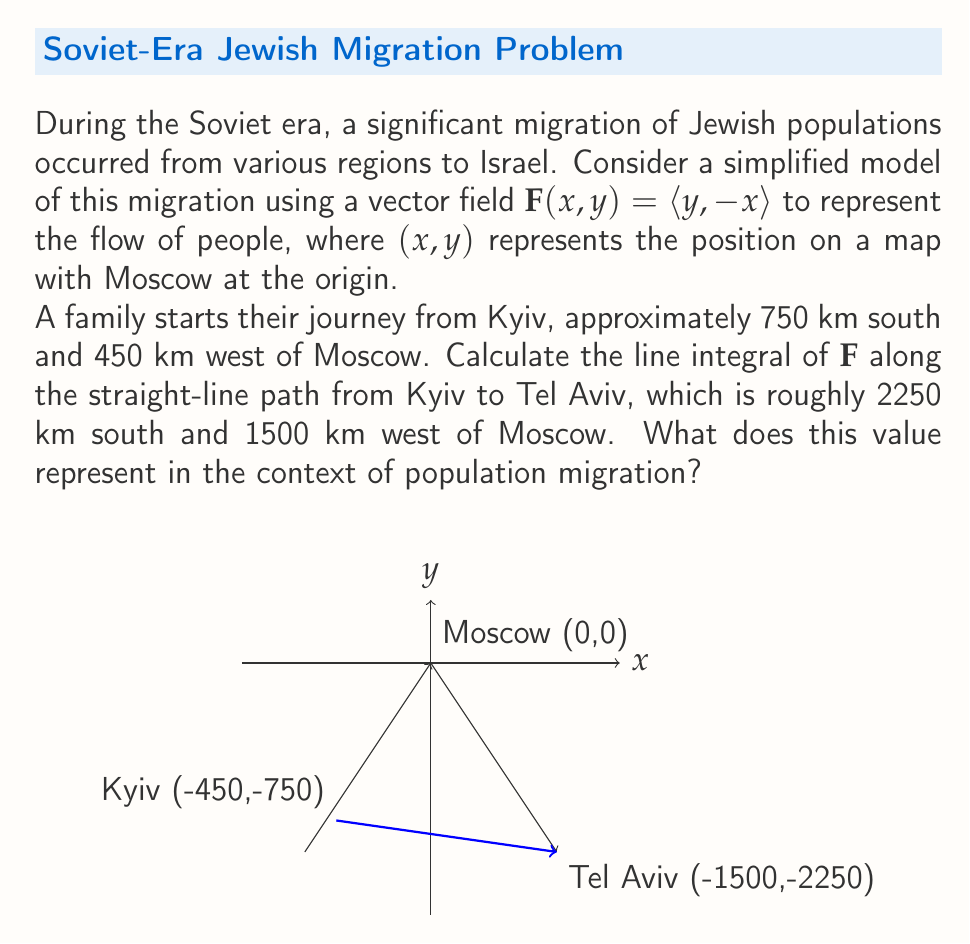Teach me how to tackle this problem. Let's approach this step-by-step:

1) The vector field is given as $\mathbf{F}(x,y) = \langle y, -x \rangle$.

2) We need to calculate the line integral of $\mathbf{F}$ along the straight line from Kyiv to Tel Aviv.

3) Let's parameterize this line. If we consider $t \in [0,1]$, we can write:
   $x(t) = -450 - 1050t$
   $y(t) = -750 - 1500t$

4) The derivative of this parametrization is:
   $\frac{dx}{dt} = -1050$
   $\frac{dy}{dt} = -1500$

5) The line integral is given by:
   $$\int_C \mathbf{F} \cdot d\mathbf{r} = \int_0^1 \mathbf{F}(x(t),y(t)) \cdot \left(\frac{dx}{dt}, \frac{dy}{dt}\right) dt$$

6) Substituting our values:
   $$\int_0^1 ((-750-1500t), (450+1050t)) \cdot (-1050, -1500) dt$$

7) Simplifying:
   $$\int_0^1 (787500 + 1575000t + 675000 + 1575000t) dt$$
   $$= \int_0^1 (1462500 + 3150000t) dt$$

8) Integrating:
   $$= [1462500t + 1575000t^2]_0^1$$
   $$= (1462500 + 1575000) - (0 + 0) = 3037500$$

9) In the context of population migration, this positive value indicates a net flow of people along this path in the direction from Kyiv to Tel Aviv, consistent with the historical Jewish migration from the Soviet Union to Israel.
Answer: 3037500 (representing net migration flow from Kyiv to Tel Aviv) 